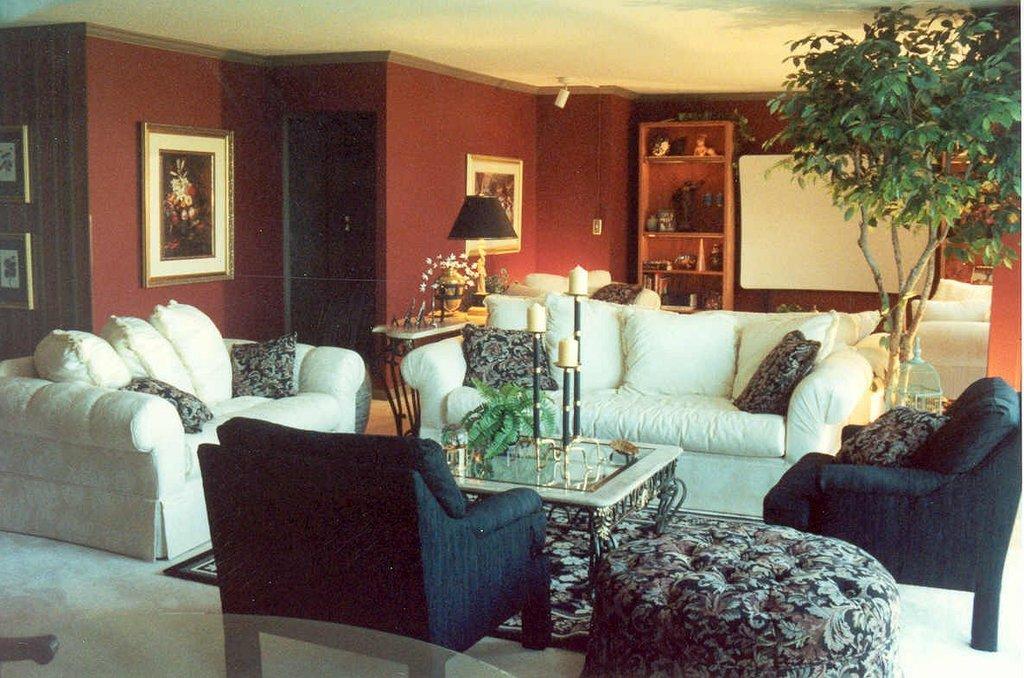Could you give a brief overview of what you see in this image? On the background we can see wall, cupboards. There are few photo frames over a wall. Here we can see few products arranged in a cupboard. This is a ceiling. Here we can see a plant. These are sofas with cushions and chairs. Here we can a table and on the table there is one house plant. This is a floor and a carpet. 